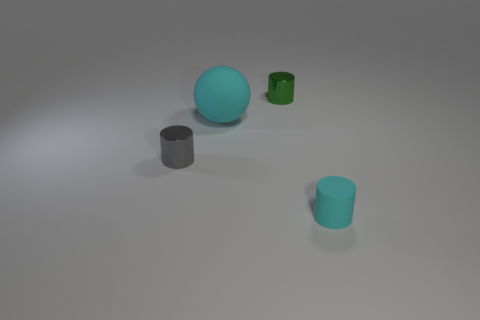There is a cyan cylinder that is the same size as the gray metal thing; what is it made of?
Keep it short and to the point. Rubber. There is a matte cylinder; does it have the same color as the matte object behind the small gray object?
Make the answer very short. Yes. Is the number of cyan things to the left of the big cyan sphere less than the number of matte balls?
Ensure brevity in your answer.  Yes. How many large yellow metal balls are there?
Offer a terse response. 0. There is a green shiny thing behind the metallic object that is in front of the green shiny object; what is its shape?
Give a very brief answer. Cylinder. How many tiny gray things are behind the green cylinder?
Offer a very short reply. 0. Is the green cylinder made of the same material as the small thing in front of the gray shiny cylinder?
Your answer should be very brief. No. Is there a gray matte cube of the same size as the green metal object?
Keep it short and to the point. No. Is the number of small cyan rubber things that are to the right of the small cyan rubber object the same as the number of gray cylinders?
Your answer should be compact. No. How big is the green object?
Your answer should be compact. Small. 